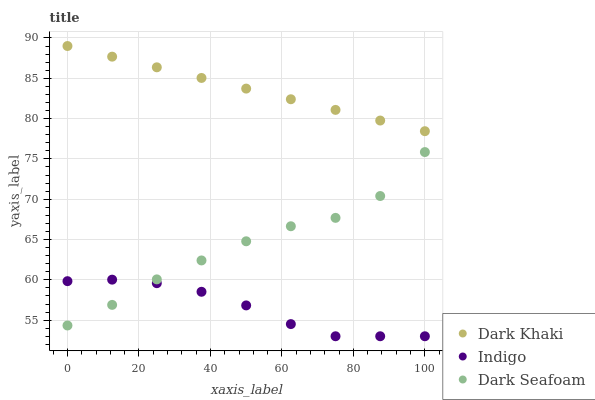Does Indigo have the minimum area under the curve?
Answer yes or no. Yes. Does Dark Khaki have the maximum area under the curve?
Answer yes or no. Yes. Does Dark Seafoam have the minimum area under the curve?
Answer yes or no. No. Does Dark Seafoam have the maximum area under the curve?
Answer yes or no. No. Is Dark Khaki the smoothest?
Answer yes or no. Yes. Is Dark Seafoam the roughest?
Answer yes or no. Yes. Is Indigo the smoothest?
Answer yes or no. No. Is Indigo the roughest?
Answer yes or no. No. Does Indigo have the lowest value?
Answer yes or no. Yes. Does Dark Seafoam have the lowest value?
Answer yes or no. No. Does Dark Khaki have the highest value?
Answer yes or no. Yes. Does Dark Seafoam have the highest value?
Answer yes or no. No. Is Dark Seafoam less than Dark Khaki?
Answer yes or no. Yes. Is Dark Khaki greater than Indigo?
Answer yes or no. Yes. Does Dark Seafoam intersect Indigo?
Answer yes or no. Yes. Is Dark Seafoam less than Indigo?
Answer yes or no. No. Is Dark Seafoam greater than Indigo?
Answer yes or no. No. Does Dark Seafoam intersect Dark Khaki?
Answer yes or no. No. 